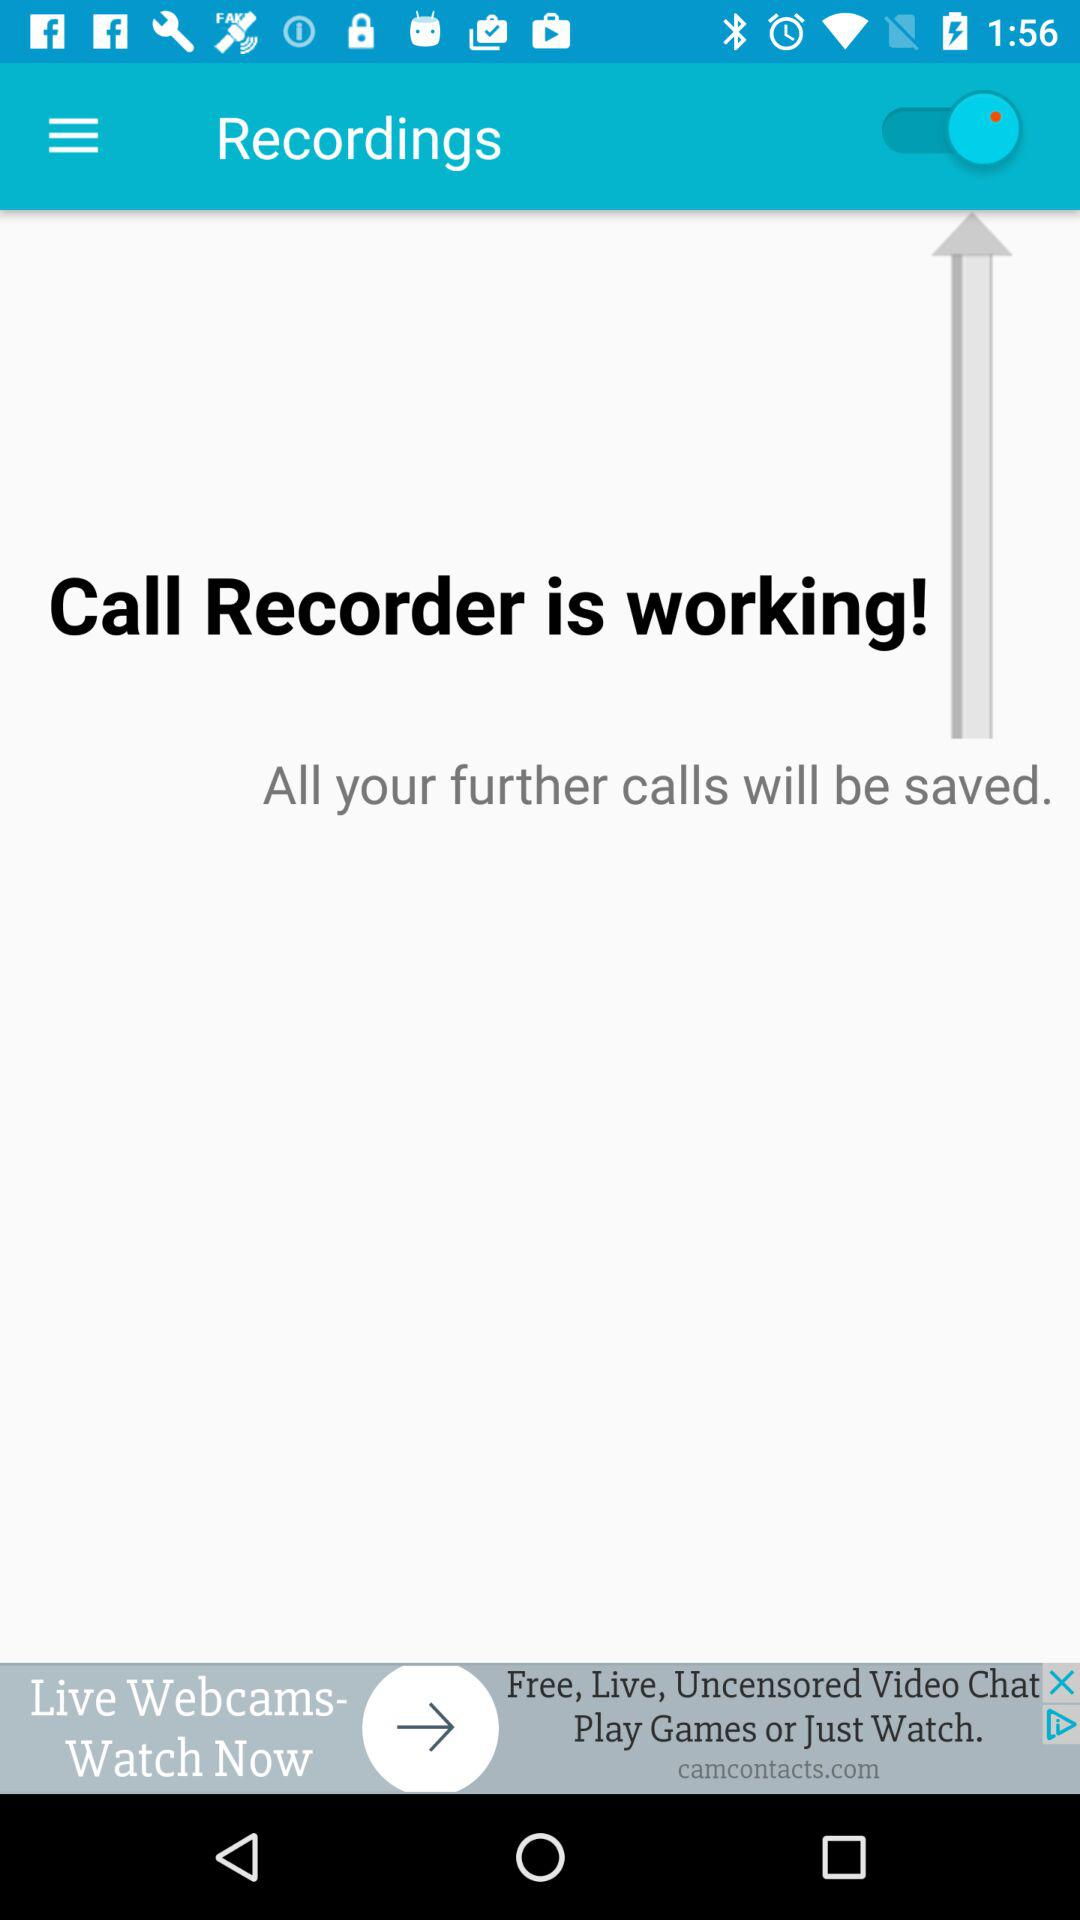What is the status of the "Recordings"? The status of the "Recordings" is "on". 